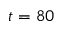Convert formula to latex. <formula><loc_0><loc_0><loc_500><loc_500>t = 8 0</formula> 